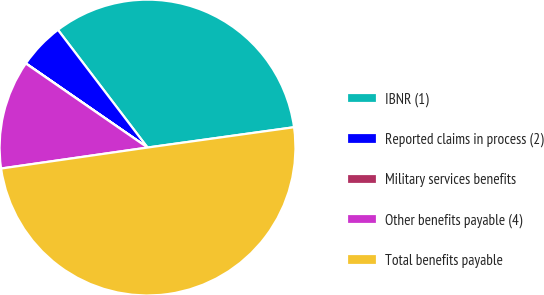Convert chart to OTSL. <chart><loc_0><loc_0><loc_500><loc_500><pie_chart><fcel>IBNR (1)<fcel>Reported claims in process (2)<fcel>Military services benefits<fcel>Other benefits payable (4)<fcel>Total benefits payable<nl><fcel>33.16%<fcel>5.01%<fcel>0.02%<fcel>11.88%<fcel>49.93%<nl></chart> 